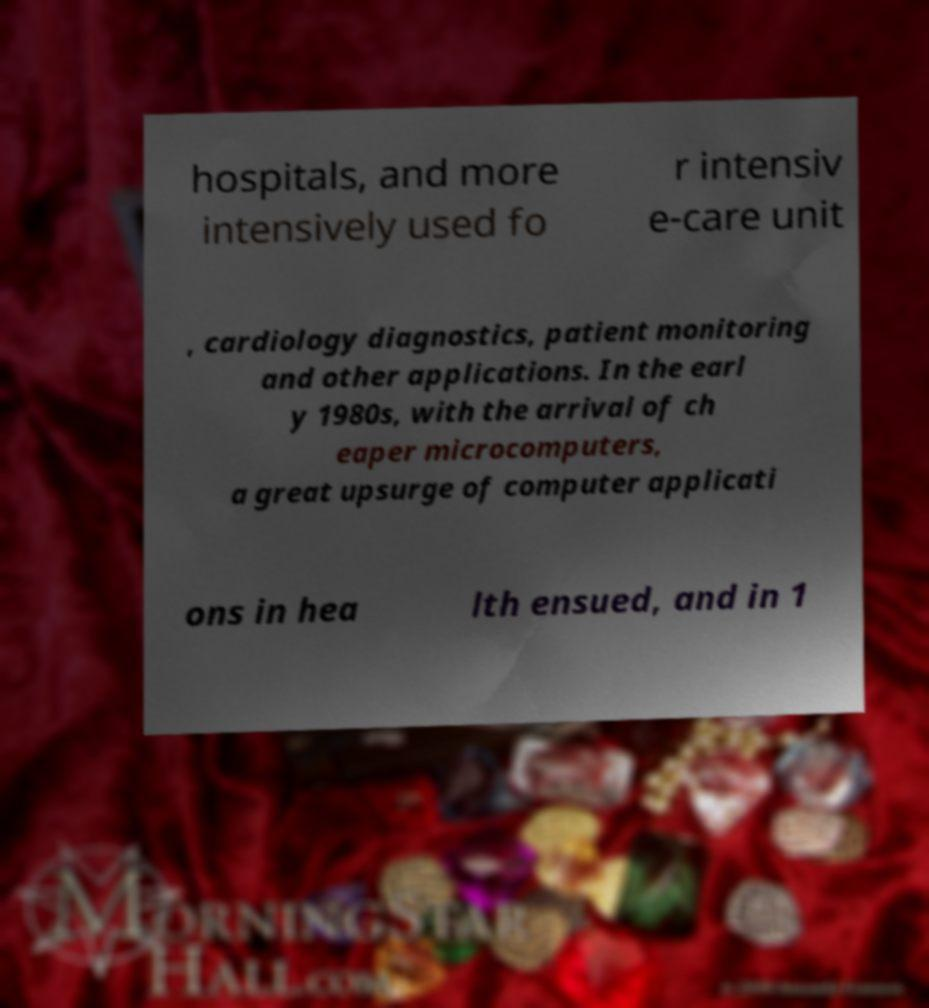Can you read and provide the text displayed in the image?This photo seems to have some interesting text. Can you extract and type it out for me? hospitals, and more intensively used fo r intensiv e-care unit , cardiology diagnostics, patient monitoring and other applications. In the earl y 1980s, with the arrival of ch eaper microcomputers, a great upsurge of computer applicati ons in hea lth ensued, and in 1 